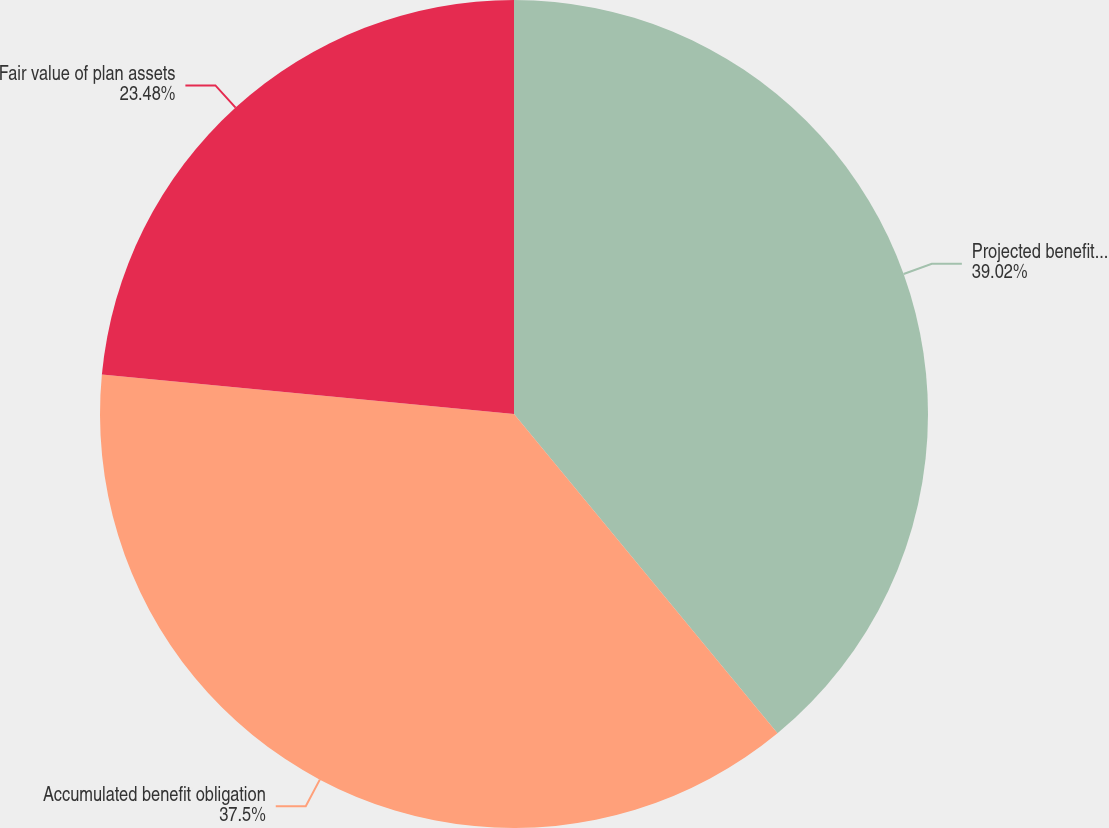Convert chart to OTSL. <chart><loc_0><loc_0><loc_500><loc_500><pie_chart><fcel>Projected benefit obligation<fcel>Accumulated benefit obligation<fcel>Fair value of plan assets<nl><fcel>39.02%<fcel>37.5%<fcel>23.48%<nl></chart> 